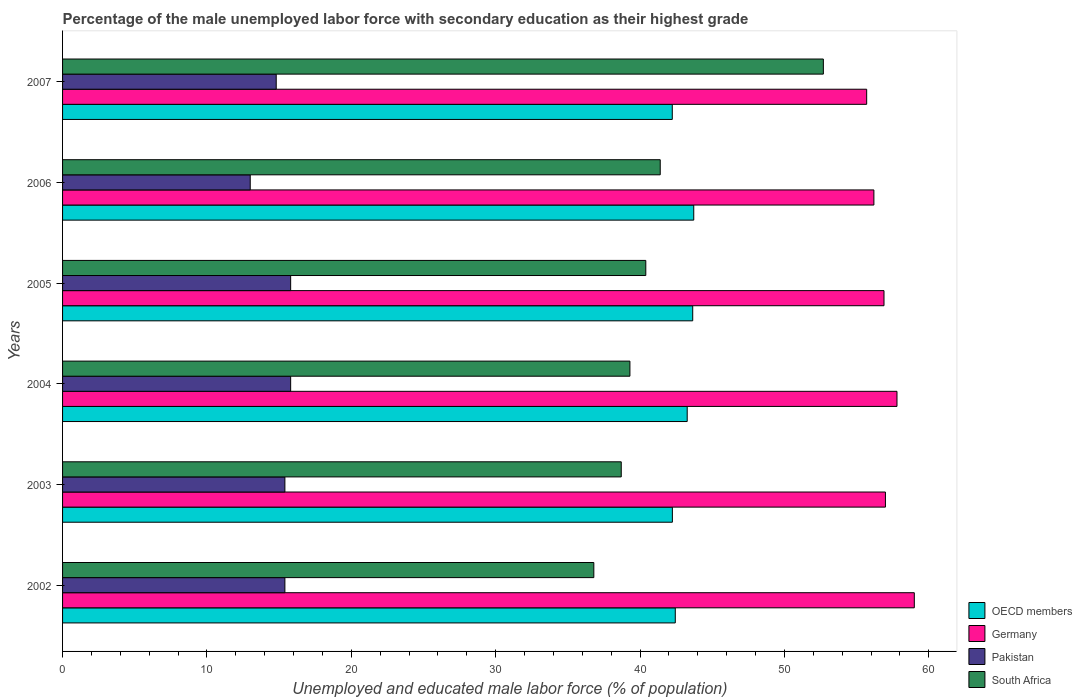How many different coloured bars are there?
Your answer should be compact. 4. Are the number of bars per tick equal to the number of legend labels?
Provide a short and direct response. Yes. Are the number of bars on each tick of the Y-axis equal?
Your answer should be compact. Yes. What is the label of the 1st group of bars from the top?
Give a very brief answer. 2007. What is the percentage of the unemployed male labor force with secondary education in OECD members in 2004?
Make the answer very short. 43.27. Across all years, what is the maximum percentage of the unemployed male labor force with secondary education in Pakistan?
Provide a short and direct response. 15.8. Across all years, what is the minimum percentage of the unemployed male labor force with secondary education in OECD members?
Your response must be concise. 42.24. What is the total percentage of the unemployed male labor force with secondary education in South Africa in the graph?
Your response must be concise. 249.3. What is the difference between the percentage of the unemployed male labor force with secondary education in South Africa in 2002 and that in 2006?
Give a very brief answer. -4.6. What is the difference between the percentage of the unemployed male labor force with secondary education in Pakistan in 2005 and the percentage of the unemployed male labor force with secondary education in South Africa in 2007?
Offer a very short reply. -36.9. What is the average percentage of the unemployed male labor force with secondary education in OECD members per year?
Your answer should be very brief. 42.93. What is the ratio of the percentage of the unemployed male labor force with secondary education in Pakistan in 2002 to that in 2005?
Offer a very short reply. 0.97. What is the difference between the highest and the second highest percentage of the unemployed male labor force with secondary education in Germany?
Make the answer very short. 1.2. What is the difference between the highest and the lowest percentage of the unemployed male labor force with secondary education in OECD members?
Make the answer very short. 1.49. Is it the case that in every year, the sum of the percentage of the unemployed male labor force with secondary education in South Africa and percentage of the unemployed male labor force with secondary education in Germany is greater than the sum of percentage of the unemployed male labor force with secondary education in OECD members and percentage of the unemployed male labor force with secondary education in Pakistan?
Offer a terse response. No. What does the 4th bar from the top in 2005 represents?
Offer a very short reply. OECD members. Is it the case that in every year, the sum of the percentage of the unemployed male labor force with secondary education in South Africa and percentage of the unemployed male labor force with secondary education in Germany is greater than the percentage of the unemployed male labor force with secondary education in OECD members?
Give a very brief answer. Yes. How many years are there in the graph?
Your answer should be very brief. 6. What is the difference between two consecutive major ticks on the X-axis?
Keep it short and to the point. 10. Does the graph contain any zero values?
Give a very brief answer. No. Does the graph contain grids?
Give a very brief answer. No. Where does the legend appear in the graph?
Your answer should be very brief. Bottom right. How many legend labels are there?
Ensure brevity in your answer.  4. What is the title of the graph?
Make the answer very short. Percentage of the male unemployed labor force with secondary education as their highest grade. What is the label or title of the X-axis?
Your response must be concise. Unemployed and educated male labor force (% of population). What is the Unemployed and educated male labor force (% of population) in OECD members in 2002?
Make the answer very short. 42.44. What is the Unemployed and educated male labor force (% of population) in Germany in 2002?
Provide a succinct answer. 59. What is the Unemployed and educated male labor force (% of population) in Pakistan in 2002?
Your answer should be compact. 15.4. What is the Unemployed and educated male labor force (% of population) in South Africa in 2002?
Provide a succinct answer. 36.8. What is the Unemployed and educated male labor force (% of population) of OECD members in 2003?
Ensure brevity in your answer.  42.24. What is the Unemployed and educated male labor force (% of population) of Germany in 2003?
Give a very brief answer. 57. What is the Unemployed and educated male labor force (% of population) in Pakistan in 2003?
Provide a succinct answer. 15.4. What is the Unemployed and educated male labor force (% of population) of South Africa in 2003?
Provide a short and direct response. 38.7. What is the Unemployed and educated male labor force (% of population) in OECD members in 2004?
Provide a succinct answer. 43.27. What is the Unemployed and educated male labor force (% of population) in Germany in 2004?
Your response must be concise. 57.8. What is the Unemployed and educated male labor force (% of population) in Pakistan in 2004?
Give a very brief answer. 15.8. What is the Unemployed and educated male labor force (% of population) of South Africa in 2004?
Your answer should be compact. 39.3. What is the Unemployed and educated male labor force (% of population) of OECD members in 2005?
Make the answer very short. 43.65. What is the Unemployed and educated male labor force (% of population) in Germany in 2005?
Offer a very short reply. 56.9. What is the Unemployed and educated male labor force (% of population) in Pakistan in 2005?
Your response must be concise. 15.8. What is the Unemployed and educated male labor force (% of population) of South Africa in 2005?
Offer a terse response. 40.4. What is the Unemployed and educated male labor force (% of population) in OECD members in 2006?
Offer a terse response. 43.72. What is the Unemployed and educated male labor force (% of population) in Germany in 2006?
Give a very brief answer. 56.2. What is the Unemployed and educated male labor force (% of population) of Pakistan in 2006?
Make the answer very short. 13. What is the Unemployed and educated male labor force (% of population) in South Africa in 2006?
Ensure brevity in your answer.  41.4. What is the Unemployed and educated male labor force (% of population) of OECD members in 2007?
Offer a very short reply. 42.24. What is the Unemployed and educated male labor force (% of population) in Germany in 2007?
Make the answer very short. 55.7. What is the Unemployed and educated male labor force (% of population) of Pakistan in 2007?
Your response must be concise. 14.8. What is the Unemployed and educated male labor force (% of population) of South Africa in 2007?
Your answer should be compact. 52.7. Across all years, what is the maximum Unemployed and educated male labor force (% of population) in OECD members?
Provide a succinct answer. 43.72. Across all years, what is the maximum Unemployed and educated male labor force (% of population) in Pakistan?
Offer a terse response. 15.8. Across all years, what is the maximum Unemployed and educated male labor force (% of population) of South Africa?
Give a very brief answer. 52.7. Across all years, what is the minimum Unemployed and educated male labor force (% of population) in OECD members?
Your answer should be very brief. 42.24. Across all years, what is the minimum Unemployed and educated male labor force (% of population) of Germany?
Ensure brevity in your answer.  55.7. Across all years, what is the minimum Unemployed and educated male labor force (% of population) in South Africa?
Provide a succinct answer. 36.8. What is the total Unemployed and educated male labor force (% of population) of OECD members in the graph?
Your answer should be very brief. 257.56. What is the total Unemployed and educated male labor force (% of population) in Germany in the graph?
Offer a terse response. 342.6. What is the total Unemployed and educated male labor force (% of population) in Pakistan in the graph?
Your response must be concise. 90.2. What is the total Unemployed and educated male labor force (% of population) in South Africa in the graph?
Keep it short and to the point. 249.3. What is the difference between the Unemployed and educated male labor force (% of population) in OECD members in 2002 and that in 2003?
Give a very brief answer. 0.2. What is the difference between the Unemployed and educated male labor force (% of population) in Germany in 2002 and that in 2003?
Ensure brevity in your answer.  2. What is the difference between the Unemployed and educated male labor force (% of population) in Pakistan in 2002 and that in 2003?
Your answer should be compact. 0. What is the difference between the Unemployed and educated male labor force (% of population) in South Africa in 2002 and that in 2003?
Provide a short and direct response. -1.9. What is the difference between the Unemployed and educated male labor force (% of population) of OECD members in 2002 and that in 2004?
Offer a terse response. -0.83. What is the difference between the Unemployed and educated male labor force (% of population) of Germany in 2002 and that in 2004?
Offer a terse response. 1.2. What is the difference between the Unemployed and educated male labor force (% of population) of OECD members in 2002 and that in 2005?
Ensure brevity in your answer.  -1.21. What is the difference between the Unemployed and educated male labor force (% of population) of Germany in 2002 and that in 2005?
Offer a terse response. 2.1. What is the difference between the Unemployed and educated male labor force (% of population) of OECD members in 2002 and that in 2006?
Keep it short and to the point. -1.28. What is the difference between the Unemployed and educated male labor force (% of population) of OECD members in 2002 and that in 2007?
Make the answer very short. 0.21. What is the difference between the Unemployed and educated male labor force (% of population) in Germany in 2002 and that in 2007?
Offer a very short reply. 3.3. What is the difference between the Unemployed and educated male labor force (% of population) in South Africa in 2002 and that in 2007?
Keep it short and to the point. -15.9. What is the difference between the Unemployed and educated male labor force (% of population) in OECD members in 2003 and that in 2004?
Your answer should be very brief. -1.03. What is the difference between the Unemployed and educated male labor force (% of population) in Germany in 2003 and that in 2004?
Ensure brevity in your answer.  -0.8. What is the difference between the Unemployed and educated male labor force (% of population) of South Africa in 2003 and that in 2004?
Provide a short and direct response. -0.6. What is the difference between the Unemployed and educated male labor force (% of population) of OECD members in 2003 and that in 2005?
Make the answer very short. -1.41. What is the difference between the Unemployed and educated male labor force (% of population) of OECD members in 2003 and that in 2006?
Make the answer very short. -1.48. What is the difference between the Unemployed and educated male labor force (% of population) in Germany in 2003 and that in 2006?
Provide a succinct answer. 0.8. What is the difference between the Unemployed and educated male labor force (% of population) in South Africa in 2003 and that in 2006?
Provide a succinct answer. -2.7. What is the difference between the Unemployed and educated male labor force (% of population) in OECD members in 2003 and that in 2007?
Keep it short and to the point. 0.01. What is the difference between the Unemployed and educated male labor force (% of population) of Pakistan in 2003 and that in 2007?
Offer a very short reply. 0.6. What is the difference between the Unemployed and educated male labor force (% of population) in South Africa in 2003 and that in 2007?
Offer a very short reply. -14. What is the difference between the Unemployed and educated male labor force (% of population) in OECD members in 2004 and that in 2005?
Provide a succinct answer. -0.38. What is the difference between the Unemployed and educated male labor force (% of population) in OECD members in 2004 and that in 2006?
Provide a short and direct response. -0.45. What is the difference between the Unemployed and educated male labor force (% of population) in Germany in 2004 and that in 2006?
Make the answer very short. 1.6. What is the difference between the Unemployed and educated male labor force (% of population) of Pakistan in 2004 and that in 2006?
Give a very brief answer. 2.8. What is the difference between the Unemployed and educated male labor force (% of population) of South Africa in 2004 and that in 2006?
Keep it short and to the point. -2.1. What is the difference between the Unemployed and educated male labor force (% of population) of OECD members in 2004 and that in 2007?
Make the answer very short. 1.03. What is the difference between the Unemployed and educated male labor force (% of population) of Pakistan in 2004 and that in 2007?
Ensure brevity in your answer.  1. What is the difference between the Unemployed and educated male labor force (% of population) in South Africa in 2004 and that in 2007?
Your response must be concise. -13.4. What is the difference between the Unemployed and educated male labor force (% of population) in OECD members in 2005 and that in 2006?
Make the answer very short. -0.07. What is the difference between the Unemployed and educated male labor force (% of population) of OECD members in 2005 and that in 2007?
Your response must be concise. 1.41. What is the difference between the Unemployed and educated male labor force (% of population) of Pakistan in 2005 and that in 2007?
Provide a succinct answer. 1. What is the difference between the Unemployed and educated male labor force (% of population) of OECD members in 2006 and that in 2007?
Offer a terse response. 1.49. What is the difference between the Unemployed and educated male labor force (% of population) of Germany in 2006 and that in 2007?
Ensure brevity in your answer.  0.5. What is the difference between the Unemployed and educated male labor force (% of population) in Pakistan in 2006 and that in 2007?
Give a very brief answer. -1.8. What is the difference between the Unemployed and educated male labor force (% of population) of OECD members in 2002 and the Unemployed and educated male labor force (% of population) of Germany in 2003?
Your response must be concise. -14.56. What is the difference between the Unemployed and educated male labor force (% of population) in OECD members in 2002 and the Unemployed and educated male labor force (% of population) in Pakistan in 2003?
Make the answer very short. 27.04. What is the difference between the Unemployed and educated male labor force (% of population) of OECD members in 2002 and the Unemployed and educated male labor force (% of population) of South Africa in 2003?
Your answer should be very brief. 3.74. What is the difference between the Unemployed and educated male labor force (% of population) of Germany in 2002 and the Unemployed and educated male labor force (% of population) of Pakistan in 2003?
Offer a terse response. 43.6. What is the difference between the Unemployed and educated male labor force (% of population) in Germany in 2002 and the Unemployed and educated male labor force (% of population) in South Africa in 2003?
Provide a succinct answer. 20.3. What is the difference between the Unemployed and educated male labor force (% of population) in Pakistan in 2002 and the Unemployed and educated male labor force (% of population) in South Africa in 2003?
Give a very brief answer. -23.3. What is the difference between the Unemployed and educated male labor force (% of population) in OECD members in 2002 and the Unemployed and educated male labor force (% of population) in Germany in 2004?
Offer a terse response. -15.36. What is the difference between the Unemployed and educated male labor force (% of population) of OECD members in 2002 and the Unemployed and educated male labor force (% of population) of Pakistan in 2004?
Keep it short and to the point. 26.64. What is the difference between the Unemployed and educated male labor force (% of population) in OECD members in 2002 and the Unemployed and educated male labor force (% of population) in South Africa in 2004?
Ensure brevity in your answer.  3.14. What is the difference between the Unemployed and educated male labor force (% of population) of Germany in 2002 and the Unemployed and educated male labor force (% of population) of Pakistan in 2004?
Provide a short and direct response. 43.2. What is the difference between the Unemployed and educated male labor force (% of population) of Germany in 2002 and the Unemployed and educated male labor force (% of population) of South Africa in 2004?
Your response must be concise. 19.7. What is the difference between the Unemployed and educated male labor force (% of population) in Pakistan in 2002 and the Unemployed and educated male labor force (% of population) in South Africa in 2004?
Your answer should be compact. -23.9. What is the difference between the Unemployed and educated male labor force (% of population) in OECD members in 2002 and the Unemployed and educated male labor force (% of population) in Germany in 2005?
Your answer should be compact. -14.46. What is the difference between the Unemployed and educated male labor force (% of population) in OECD members in 2002 and the Unemployed and educated male labor force (% of population) in Pakistan in 2005?
Give a very brief answer. 26.64. What is the difference between the Unemployed and educated male labor force (% of population) of OECD members in 2002 and the Unemployed and educated male labor force (% of population) of South Africa in 2005?
Offer a very short reply. 2.04. What is the difference between the Unemployed and educated male labor force (% of population) of Germany in 2002 and the Unemployed and educated male labor force (% of population) of Pakistan in 2005?
Make the answer very short. 43.2. What is the difference between the Unemployed and educated male labor force (% of population) in Pakistan in 2002 and the Unemployed and educated male labor force (% of population) in South Africa in 2005?
Offer a terse response. -25. What is the difference between the Unemployed and educated male labor force (% of population) in OECD members in 2002 and the Unemployed and educated male labor force (% of population) in Germany in 2006?
Provide a short and direct response. -13.76. What is the difference between the Unemployed and educated male labor force (% of population) in OECD members in 2002 and the Unemployed and educated male labor force (% of population) in Pakistan in 2006?
Give a very brief answer. 29.44. What is the difference between the Unemployed and educated male labor force (% of population) of OECD members in 2002 and the Unemployed and educated male labor force (% of population) of South Africa in 2006?
Ensure brevity in your answer.  1.04. What is the difference between the Unemployed and educated male labor force (% of population) in Germany in 2002 and the Unemployed and educated male labor force (% of population) in Pakistan in 2006?
Your answer should be compact. 46. What is the difference between the Unemployed and educated male labor force (% of population) in Germany in 2002 and the Unemployed and educated male labor force (% of population) in South Africa in 2006?
Offer a very short reply. 17.6. What is the difference between the Unemployed and educated male labor force (% of population) of Pakistan in 2002 and the Unemployed and educated male labor force (% of population) of South Africa in 2006?
Make the answer very short. -26. What is the difference between the Unemployed and educated male labor force (% of population) in OECD members in 2002 and the Unemployed and educated male labor force (% of population) in Germany in 2007?
Provide a short and direct response. -13.26. What is the difference between the Unemployed and educated male labor force (% of population) of OECD members in 2002 and the Unemployed and educated male labor force (% of population) of Pakistan in 2007?
Give a very brief answer. 27.64. What is the difference between the Unemployed and educated male labor force (% of population) of OECD members in 2002 and the Unemployed and educated male labor force (% of population) of South Africa in 2007?
Provide a short and direct response. -10.26. What is the difference between the Unemployed and educated male labor force (% of population) of Germany in 2002 and the Unemployed and educated male labor force (% of population) of Pakistan in 2007?
Give a very brief answer. 44.2. What is the difference between the Unemployed and educated male labor force (% of population) in Germany in 2002 and the Unemployed and educated male labor force (% of population) in South Africa in 2007?
Your answer should be very brief. 6.3. What is the difference between the Unemployed and educated male labor force (% of population) in Pakistan in 2002 and the Unemployed and educated male labor force (% of population) in South Africa in 2007?
Make the answer very short. -37.3. What is the difference between the Unemployed and educated male labor force (% of population) in OECD members in 2003 and the Unemployed and educated male labor force (% of population) in Germany in 2004?
Offer a very short reply. -15.56. What is the difference between the Unemployed and educated male labor force (% of population) in OECD members in 2003 and the Unemployed and educated male labor force (% of population) in Pakistan in 2004?
Give a very brief answer. 26.44. What is the difference between the Unemployed and educated male labor force (% of population) of OECD members in 2003 and the Unemployed and educated male labor force (% of population) of South Africa in 2004?
Offer a very short reply. 2.94. What is the difference between the Unemployed and educated male labor force (% of population) in Germany in 2003 and the Unemployed and educated male labor force (% of population) in Pakistan in 2004?
Keep it short and to the point. 41.2. What is the difference between the Unemployed and educated male labor force (% of population) in Germany in 2003 and the Unemployed and educated male labor force (% of population) in South Africa in 2004?
Offer a terse response. 17.7. What is the difference between the Unemployed and educated male labor force (% of population) in Pakistan in 2003 and the Unemployed and educated male labor force (% of population) in South Africa in 2004?
Give a very brief answer. -23.9. What is the difference between the Unemployed and educated male labor force (% of population) in OECD members in 2003 and the Unemployed and educated male labor force (% of population) in Germany in 2005?
Keep it short and to the point. -14.66. What is the difference between the Unemployed and educated male labor force (% of population) in OECD members in 2003 and the Unemployed and educated male labor force (% of population) in Pakistan in 2005?
Your answer should be very brief. 26.44. What is the difference between the Unemployed and educated male labor force (% of population) in OECD members in 2003 and the Unemployed and educated male labor force (% of population) in South Africa in 2005?
Ensure brevity in your answer.  1.84. What is the difference between the Unemployed and educated male labor force (% of population) in Germany in 2003 and the Unemployed and educated male labor force (% of population) in Pakistan in 2005?
Keep it short and to the point. 41.2. What is the difference between the Unemployed and educated male labor force (% of population) in Germany in 2003 and the Unemployed and educated male labor force (% of population) in South Africa in 2005?
Keep it short and to the point. 16.6. What is the difference between the Unemployed and educated male labor force (% of population) in Pakistan in 2003 and the Unemployed and educated male labor force (% of population) in South Africa in 2005?
Make the answer very short. -25. What is the difference between the Unemployed and educated male labor force (% of population) in OECD members in 2003 and the Unemployed and educated male labor force (% of population) in Germany in 2006?
Make the answer very short. -13.96. What is the difference between the Unemployed and educated male labor force (% of population) of OECD members in 2003 and the Unemployed and educated male labor force (% of population) of Pakistan in 2006?
Offer a very short reply. 29.24. What is the difference between the Unemployed and educated male labor force (% of population) in OECD members in 2003 and the Unemployed and educated male labor force (% of population) in South Africa in 2006?
Your response must be concise. 0.84. What is the difference between the Unemployed and educated male labor force (% of population) in Germany in 2003 and the Unemployed and educated male labor force (% of population) in South Africa in 2006?
Keep it short and to the point. 15.6. What is the difference between the Unemployed and educated male labor force (% of population) in OECD members in 2003 and the Unemployed and educated male labor force (% of population) in Germany in 2007?
Offer a terse response. -13.46. What is the difference between the Unemployed and educated male labor force (% of population) of OECD members in 2003 and the Unemployed and educated male labor force (% of population) of Pakistan in 2007?
Provide a succinct answer. 27.44. What is the difference between the Unemployed and educated male labor force (% of population) of OECD members in 2003 and the Unemployed and educated male labor force (% of population) of South Africa in 2007?
Provide a short and direct response. -10.46. What is the difference between the Unemployed and educated male labor force (% of population) of Germany in 2003 and the Unemployed and educated male labor force (% of population) of Pakistan in 2007?
Make the answer very short. 42.2. What is the difference between the Unemployed and educated male labor force (% of population) of Germany in 2003 and the Unemployed and educated male labor force (% of population) of South Africa in 2007?
Offer a terse response. 4.3. What is the difference between the Unemployed and educated male labor force (% of population) in Pakistan in 2003 and the Unemployed and educated male labor force (% of population) in South Africa in 2007?
Make the answer very short. -37.3. What is the difference between the Unemployed and educated male labor force (% of population) in OECD members in 2004 and the Unemployed and educated male labor force (% of population) in Germany in 2005?
Offer a terse response. -13.63. What is the difference between the Unemployed and educated male labor force (% of population) of OECD members in 2004 and the Unemployed and educated male labor force (% of population) of Pakistan in 2005?
Offer a terse response. 27.47. What is the difference between the Unemployed and educated male labor force (% of population) of OECD members in 2004 and the Unemployed and educated male labor force (% of population) of South Africa in 2005?
Your answer should be very brief. 2.87. What is the difference between the Unemployed and educated male labor force (% of population) of Germany in 2004 and the Unemployed and educated male labor force (% of population) of Pakistan in 2005?
Provide a short and direct response. 42. What is the difference between the Unemployed and educated male labor force (% of population) of Pakistan in 2004 and the Unemployed and educated male labor force (% of population) of South Africa in 2005?
Offer a very short reply. -24.6. What is the difference between the Unemployed and educated male labor force (% of population) in OECD members in 2004 and the Unemployed and educated male labor force (% of population) in Germany in 2006?
Offer a terse response. -12.93. What is the difference between the Unemployed and educated male labor force (% of population) of OECD members in 2004 and the Unemployed and educated male labor force (% of population) of Pakistan in 2006?
Provide a short and direct response. 30.27. What is the difference between the Unemployed and educated male labor force (% of population) of OECD members in 2004 and the Unemployed and educated male labor force (% of population) of South Africa in 2006?
Keep it short and to the point. 1.87. What is the difference between the Unemployed and educated male labor force (% of population) of Germany in 2004 and the Unemployed and educated male labor force (% of population) of Pakistan in 2006?
Your answer should be compact. 44.8. What is the difference between the Unemployed and educated male labor force (% of population) in Pakistan in 2004 and the Unemployed and educated male labor force (% of population) in South Africa in 2006?
Keep it short and to the point. -25.6. What is the difference between the Unemployed and educated male labor force (% of population) in OECD members in 2004 and the Unemployed and educated male labor force (% of population) in Germany in 2007?
Your answer should be very brief. -12.43. What is the difference between the Unemployed and educated male labor force (% of population) of OECD members in 2004 and the Unemployed and educated male labor force (% of population) of Pakistan in 2007?
Ensure brevity in your answer.  28.47. What is the difference between the Unemployed and educated male labor force (% of population) in OECD members in 2004 and the Unemployed and educated male labor force (% of population) in South Africa in 2007?
Ensure brevity in your answer.  -9.43. What is the difference between the Unemployed and educated male labor force (% of population) in Germany in 2004 and the Unemployed and educated male labor force (% of population) in Pakistan in 2007?
Provide a short and direct response. 43. What is the difference between the Unemployed and educated male labor force (% of population) of Pakistan in 2004 and the Unemployed and educated male labor force (% of population) of South Africa in 2007?
Provide a short and direct response. -36.9. What is the difference between the Unemployed and educated male labor force (% of population) in OECD members in 2005 and the Unemployed and educated male labor force (% of population) in Germany in 2006?
Offer a terse response. -12.55. What is the difference between the Unemployed and educated male labor force (% of population) in OECD members in 2005 and the Unemployed and educated male labor force (% of population) in Pakistan in 2006?
Your answer should be very brief. 30.65. What is the difference between the Unemployed and educated male labor force (% of population) of OECD members in 2005 and the Unemployed and educated male labor force (% of population) of South Africa in 2006?
Provide a short and direct response. 2.25. What is the difference between the Unemployed and educated male labor force (% of population) of Germany in 2005 and the Unemployed and educated male labor force (% of population) of Pakistan in 2006?
Ensure brevity in your answer.  43.9. What is the difference between the Unemployed and educated male labor force (% of population) in Germany in 2005 and the Unemployed and educated male labor force (% of population) in South Africa in 2006?
Your response must be concise. 15.5. What is the difference between the Unemployed and educated male labor force (% of population) in Pakistan in 2005 and the Unemployed and educated male labor force (% of population) in South Africa in 2006?
Offer a very short reply. -25.6. What is the difference between the Unemployed and educated male labor force (% of population) of OECD members in 2005 and the Unemployed and educated male labor force (% of population) of Germany in 2007?
Provide a short and direct response. -12.05. What is the difference between the Unemployed and educated male labor force (% of population) in OECD members in 2005 and the Unemployed and educated male labor force (% of population) in Pakistan in 2007?
Provide a succinct answer. 28.85. What is the difference between the Unemployed and educated male labor force (% of population) of OECD members in 2005 and the Unemployed and educated male labor force (% of population) of South Africa in 2007?
Give a very brief answer. -9.05. What is the difference between the Unemployed and educated male labor force (% of population) of Germany in 2005 and the Unemployed and educated male labor force (% of population) of Pakistan in 2007?
Your answer should be compact. 42.1. What is the difference between the Unemployed and educated male labor force (% of population) in Pakistan in 2005 and the Unemployed and educated male labor force (% of population) in South Africa in 2007?
Make the answer very short. -36.9. What is the difference between the Unemployed and educated male labor force (% of population) of OECD members in 2006 and the Unemployed and educated male labor force (% of population) of Germany in 2007?
Your response must be concise. -11.98. What is the difference between the Unemployed and educated male labor force (% of population) in OECD members in 2006 and the Unemployed and educated male labor force (% of population) in Pakistan in 2007?
Ensure brevity in your answer.  28.92. What is the difference between the Unemployed and educated male labor force (% of population) in OECD members in 2006 and the Unemployed and educated male labor force (% of population) in South Africa in 2007?
Your response must be concise. -8.98. What is the difference between the Unemployed and educated male labor force (% of population) in Germany in 2006 and the Unemployed and educated male labor force (% of population) in Pakistan in 2007?
Make the answer very short. 41.4. What is the difference between the Unemployed and educated male labor force (% of population) of Germany in 2006 and the Unemployed and educated male labor force (% of population) of South Africa in 2007?
Make the answer very short. 3.5. What is the difference between the Unemployed and educated male labor force (% of population) in Pakistan in 2006 and the Unemployed and educated male labor force (% of population) in South Africa in 2007?
Your response must be concise. -39.7. What is the average Unemployed and educated male labor force (% of population) in OECD members per year?
Offer a terse response. 42.93. What is the average Unemployed and educated male labor force (% of population) in Germany per year?
Give a very brief answer. 57.1. What is the average Unemployed and educated male labor force (% of population) in Pakistan per year?
Provide a short and direct response. 15.03. What is the average Unemployed and educated male labor force (% of population) of South Africa per year?
Keep it short and to the point. 41.55. In the year 2002, what is the difference between the Unemployed and educated male labor force (% of population) of OECD members and Unemployed and educated male labor force (% of population) of Germany?
Make the answer very short. -16.56. In the year 2002, what is the difference between the Unemployed and educated male labor force (% of population) of OECD members and Unemployed and educated male labor force (% of population) of Pakistan?
Provide a succinct answer. 27.04. In the year 2002, what is the difference between the Unemployed and educated male labor force (% of population) in OECD members and Unemployed and educated male labor force (% of population) in South Africa?
Make the answer very short. 5.64. In the year 2002, what is the difference between the Unemployed and educated male labor force (% of population) of Germany and Unemployed and educated male labor force (% of population) of Pakistan?
Provide a short and direct response. 43.6. In the year 2002, what is the difference between the Unemployed and educated male labor force (% of population) of Germany and Unemployed and educated male labor force (% of population) of South Africa?
Offer a terse response. 22.2. In the year 2002, what is the difference between the Unemployed and educated male labor force (% of population) of Pakistan and Unemployed and educated male labor force (% of population) of South Africa?
Keep it short and to the point. -21.4. In the year 2003, what is the difference between the Unemployed and educated male labor force (% of population) of OECD members and Unemployed and educated male labor force (% of population) of Germany?
Keep it short and to the point. -14.76. In the year 2003, what is the difference between the Unemployed and educated male labor force (% of population) in OECD members and Unemployed and educated male labor force (% of population) in Pakistan?
Your answer should be compact. 26.84. In the year 2003, what is the difference between the Unemployed and educated male labor force (% of population) of OECD members and Unemployed and educated male labor force (% of population) of South Africa?
Ensure brevity in your answer.  3.54. In the year 2003, what is the difference between the Unemployed and educated male labor force (% of population) in Germany and Unemployed and educated male labor force (% of population) in Pakistan?
Provide a succinct answer. 41.6. In the year 2003, what is the difference between the Unemployed and educated male labor force (% of population) in Pakistan and Unemployed and educated male labor force (% of population) in South Africa?
Offer a terse response. -23.3. In the year 2004, what is the difference between the Unemployed and educated male labor force (% of population) in OECD members and Unemployed and educated male labor force (% of population) in Germany?
Offer a very short reply. -14.53. In the year 2004, what is the difference between the Unemployed and educated male labor force (% of population) in OECD members and Unemployed and educated male labor force (% of population) in Pakistan?
Offer a terse response. 27.47. In the year 2004, what is the difference between the Unemployed and educated male labor force (% of population) in OECD members and Unemployed and educated male labor force (% of population) in South Africa?
Your response must be concise. 3.97. In the year 2004, what is the difference between the Unemployed and educated male labor force (% of population) in Pakistan and Unemployed and educated male labor force (% of population) in South Africa?
Give a very brief answer. -23.5. In the year 2005, what is the difference between the Unemployed and educated male labor force (% of population) of OECD members and Unemployed and educated male labor force (% of population) of Germany?
Your response must be concise. -13.25. In the year 2005, what is the difference between the Unemployed and educated male labor force (% of population) in OECD members and Unemployed and educated male labor force (% of population) in Pakistan?
Your answer should be very brief. 27.85. In the year 2005, what is the difference between the Unemployed and educated male labor force (% of population) of OECD members and Unemployed and educated male labor force (% of population) of South Africa?
Your answer should be very brief. 3.25. In the year 2005, what is the difference between the Unemployed and educated male labor force (% of population) in Germany and Unemployed and educated male labor force (% of population) in Pakistan?
Offer a terse response. 41.1. In the year 2005, what is the difference between the Unemployed and educated male labor force (% of population) of Pakistan and Unemployed and educated male labor force (% of population) of South Africa?
Make the answer very short. -24.6. In the year 2006, what is the difference between the Unemployed and educated male labor force (% of population) of OECD members and Unemployed and educated male labor force (% of population) of Germany?
Offer a terse response. -12.48. In the year 2006, what is the difference between the Unemployed and educated male labor force (% of population) in OECD members and Unemployed and educated male labor force (% of population) in Pakistan?
Your answer should be compact. 30.72. In the year 2006, what is the difference between the Unemployed and educated male labor force (% of population) of OECD members and Unemployed and educated male labor force (% of population) of South Africa?
Your response must be concise. 2.32. In the year 2006, what is the difference between the Unemployed and educated male labor force (% of population) of Germany and Unemployed and educated male labor force (% of population) of Pakistan?
Your answer should be very brief. 43.2. In the year 2006, what is the difference between the Unemployed and educated male labor force (% of population) in Germany and Unemployed and educated male labor force (% of population) in South Africa?
Give a very brief answer. 14.8. In the year 2006, what is the difference between the Unemployed and educated male labor force (% of population) of Pakistan and Unemployed and educated male labor force (% of population) of South Africa?
Your answer should be compact. -28.4. In the year 2007, what is the difference between the Unemployed and educated male labor force (% of population) of OECD members and Unemployed and educated male labor force (% of population) of Germany?
Your answer should be compact. -13.46. In the year 2007, what is the difference between the Unemployed and educated male labor force (% of population) of OECD members and Unemployed and educated male labor force (% of population) of Pakistan?
Provide a short and direct response. 27.44. In the year 2007, what is the difference between the Unemployed and educated male labor force (% of population) in OECD members and Unemployed and educated male labor force (% of population) in South Africa?
Your answer should be very brief. -10.46. In the year 2007, what is the difference between the Unemployed and educated male labor force (% of population) of Germany and Unemployed and educated male labor force (% of population) of Pakistan?
Keep it short and to the point. 40.9. In the year 2007, what is the difference between the Unemployed and educated male labor force (% of population) in Pakistan and Unemployed and educated male labor force (% of population) in South Africa?
Provide a succinct answer. -37.9. What is the ratio of the Unemployed and educated male labor force (% of population) in Germany in 2002 to that in 2003?
Keep it short and to the point. 1.04. What is the ratio of the Unemployed and educated male labor force (% of population) in Pakistan in 2002 to that in 2003?
Offer a terse response. 1. What is the ratio of the Unemployed and educated male labor force (% of population) of South Africa in 2002 to that in 2003?
Give a very brief answer. 0.95. What is the ratio of the Unemployed and educated male labor force (% of population) of OECD members in 2002 to that in 2004?
Offer a terse response. 0.98. What is the ratio of the Unemployed and educated male labor force (% of population) of Germany in 2002 to that in 2004?
Your answer should be very brief. 1.02. What is the ratio of the Unemployed and educated male labor force (% of population) of Pakistan in 2002 to that in 2004?
Offer a very short reply. 0.97. What is the ratio of the Unemployed and educated male labor force (% of population) in South Africa in 2002 to that in 2004?
Your answer should be very brief. 0.94. What is the ratio of the Unemployed and educated male labor force (% of population) in OECD members in 2002 to that in 2005?
Offer a terse response. 0.97. What is the ratio of the Unemployed and educated male labor force (% of population) in Germany in 2002 to that in 2005?
Provide a succinct answer. 1.04. What is the ratio of the Unemployed and educated male labor force (% of population) of Pakistan in 2002 to that in 2005?
Provide a short and direct response. 0.97. What is the ratio of the Unemployed and educated male labor force (% of population) of South Africa in 2002 to that in 2005?
Your answer should be compact. 0.91. What is the ratio of the Unemployed and educated male labor force (% of population) of OECD members in 2002 to that in 2006?
Provide a short and direct response. 0.97. What is the ratio of the Unemployed and educated male labor force (% of population) in Germany in 2002 to that in 2006?
Offer a very short reply. 1.05. What is the ratio of the Unemployed and educated male labor force (% of population) of Pakistan in 2002 to that in 2006?
Provide a succinct answer. 1.18. What is the ratio of the Unemployed and educated male labor force (% of population) in Germany in 2002 to that in 2007?
Your answer should be compact. 1.06. What is the ratio of the Unemployed and educated male labor force (% of population) in Pakistan in 2002 to that in 2007?
Provide a succinct answer. 1.04. What is the ratio of the Unemployed and educated male labor force (% of population) of South Africa in 2002 to that in 2007?
Keep it short and to the point. 0.7. What is the ratio of the Unemployed and educated male labor force (% of population) in OECD members in 2003 to that in 2004?
Give a very brief answer. 0.98. What is the ratio of the Unemployed and educated male labor force (% of population) in Germany in 2003 to that in 2004?
Keep it short and to the point. 0.99. What is the ratio of the Unemployed and educated male labor force (% of population) in Pakistan in 2003 to that in 2004?
Keep it short and to the point. 0.97. What is the ratio of the Unemployed and educated male labor force (% of population) in South Africa in 2003 to that in 2004?
Your answer should be compact. 0.98. What is the ratio of the Unemployed and educated male labor force (% of population) of OECD members in 2003 to that in 2005?
Give a very brief answer. 0.97. What is the ratio of the Unemployed and educated male labor force (% of population) of Germany in 2003 to that in 2005?
Your response must be concise. 1. What is the ratio of the Unemployed and educated male labor force (% of population) of Pakistan in 2003 to that in 2005?
Give a very brief answer. 0.97. What is the ratio of the Unemployed and educated male labor force (% of population) in South Africa in 2003 to that in 2005?
Offer a very short reply. 0.96. What is the ratio of the Unemployed and educated male labor force (% of population) in OECD members in 2003 to that in 2006?
Ensure brevity in your answer.  0.97. What is the ratio of the Unemployed and educated male labor force (% of population) of Germany in 2003 to that in 2006?
Your answer should be very brief. 1.01. What is the ratio of the Unemployed and educated male labor force (% of population) in Pakistan in 2003 to that in 2006?
Offer a terse response. 1.18. What is the ratio of the Unemployed and educated male labor force (% of population) in South Africa in 2003 to that in 2006?
Your answer should be very brief. 0.93. What is the ratio of the Unemployed and educated male labor force (% of population) of Germany in 2003 to that in 2007?
Ensure brevity in your answer.  1.02. What is the ratio of the Unemployed and educated male labor force (% of population) in Pakistan in 2003 to that in 2007?
Offer a very short reply. 1.04. What is the ratio of the Unemployed and educated male labor force (% of population) in South Africa in 2003 to that in 2007?
Provide a short and direct response. 0.73. What is the ratio of the Unemployed and educated male labor force (% of population) of Germany in 2004 to that in 2005?
Provide a succinct answer. 1.02. What is the ratio of the Unemployed and educated male labor force (% of population) in South Africa in 2004 to that in 2005?
Your answer should be compact. 0.97. What is the ratio of the Unemployed and educated male labor force (% of population) of Germany in 2004 to that in 2006?
Ensure brevity in your answer.  1.03. What is the ratio of the Unemployed and educated male labor force (% of population) of Pakistan in 2004 to that in 2006?
Provide a succinct answer. 1.22. What is the ratio of the Unemployed and educated male labor force (% of population) of South Africa in 2004 to that in 2006?
Ensure brevity in your answer.  0.95. What is the ratio of the Unemployed and educated male labor force (% of population) of OECD members in 2004 to that in 2007?
Your response must be concise. 1.02. What is the ratio of the Unemployed and educated male labor force (% of population) in Germany in 2004 to that in 2007?
Your response must be concise. 1.04. What is the ratio of the Unemployed and educated male labor force (% of population) of Pakistan in 2004 to that in 2007?
Keep it short and to the point. 1.07. What is the ratio of the Unemployed and educated male labor force (% of population) in South Africa in 2004 to that in 2007?
Make the answer very short. 0.75. What is the ratio of the Unemployed and educated male labor force (% of population) in Germany in 2005 to that in 2006?
Provide a succinct answer. 1.01. What is the ratio of the Unemployed and educated male labor force (% of population) of Pakistan in 2005 to that in 2006?
Ensure brevity in your answer.  1.22. What is the ratio of the Unemployed and educated male labor force (% of population) of South Africa in 2005 to that in 2006?
Ensure brevity in your answer.  0.98. What is the ratio of the Unemployed and educated male labor force (% of population) in OECD members in 2005 to that in 2007?
Provide a succinct answer. 1.03. What is the ratio of the Unemployed and educated male labor force (% of population) in Germany in 2005 to that in 2007?
Offer a terse response. 1.02. What is the ratio of the Unemployed and educated male labor force (% of population) of Pakistan in 2005 to that in 2007?
Keep it short and to the point. 1.07. What is the ratio of the Unemployed and educated male labor force (% of population) of South Africa in 2005 to that in 2007?
Provide a succinct answer. 0.77. What is the ratio of the Unemployed and educated male labor force (% of population) in OECD members in 2006 to that in 2007?
Your response must be concise. 1.04. What is the ratio of the Unemployed and educated male labor force (% of population) of Germany in 2006 to that in 2007?
Provide a succinct answer. 1.01. What is the ratio of the Unemployed and educated male labor force (% of population) of Pakistan in 2006 to that in 2007?
Provide a short and direct response. 0.88. What is the ratio of the Unemployed and educated male labor force (% of population) in South Africa in 2006 to that in 2007?
Provide a short and direct response. 0.79. What is the difference between the highest and the second highest Unemployed and educated male labor force (% of population) in OECD members?
Offer a terse response. 0.07. What is the difference between the highest and the second highest Unemployed and educated male labor force (% of population) in Pakistan?
Your response must be concise. 0. What is the difference between the highest and the second highest Unemployed and educated male labor force (% of population) in South Africa?
Provide a short and direct response. 11.3. What is the difference between the highest and the lowest Unemployed and educated male labor force (% of population) in OECD members?
Your response must be concise. 1.49. What is the difference between the highest and the lowest Unemployed and educated male labor force (% of population) in South Africa?
Offer a very short reply. 15.9. 